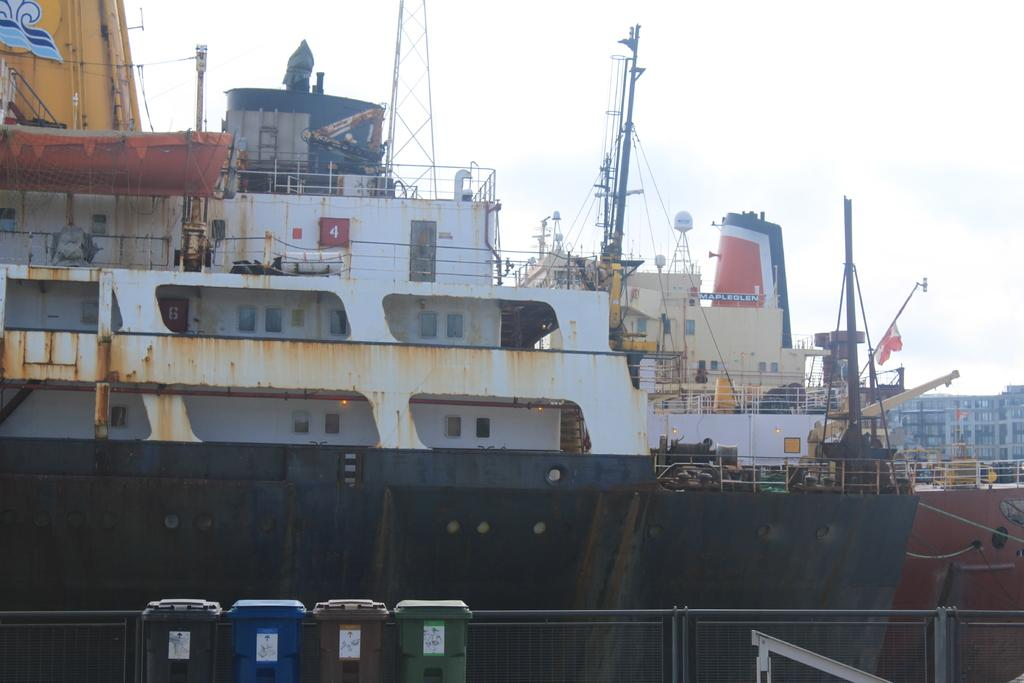<image>
Give a short and clear explanation of the subsequent image. A large black and white rusty ship called the Mapleglen at dock behind some small garbage bins. 